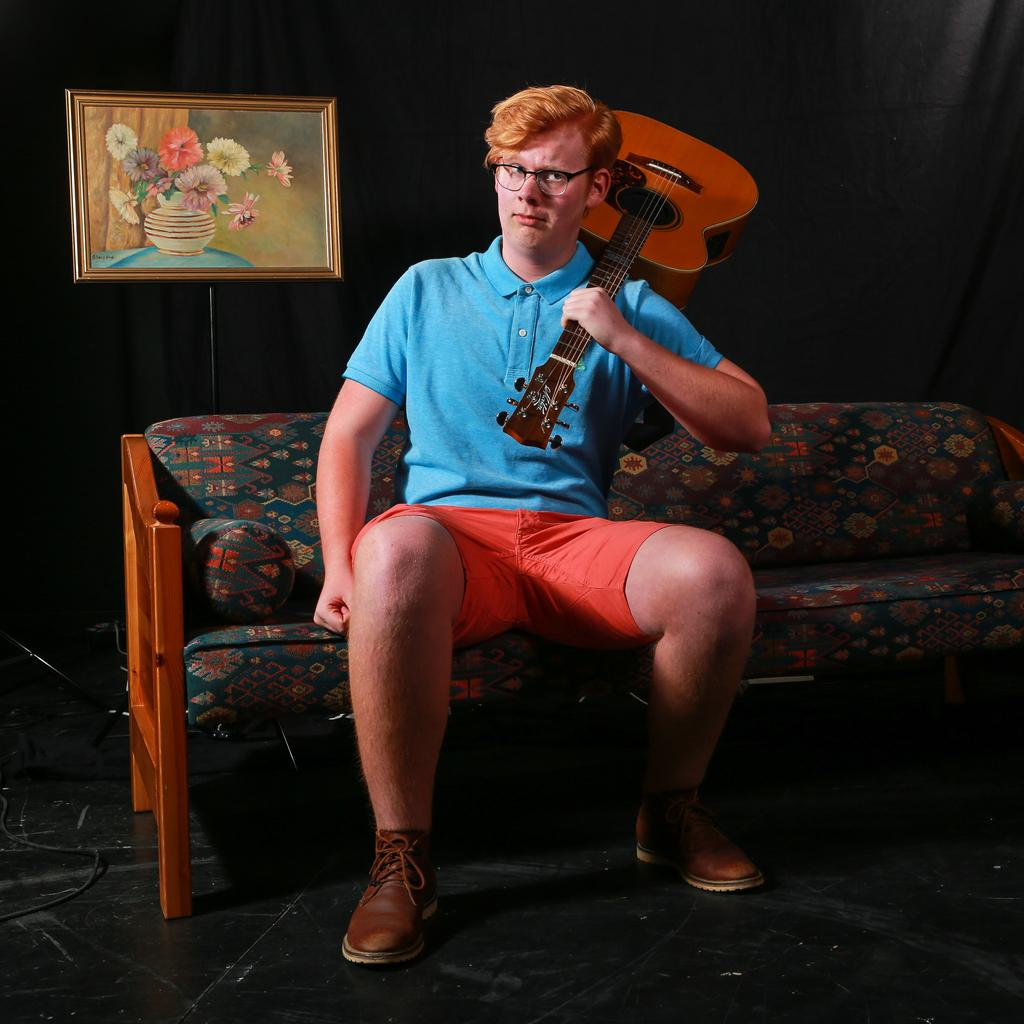What is the person in the image doing? The person is sitting on a sofa and holding a guitar on their shoulder. What can be seen in the background of the image? There is a black color curtain and a frame in the background of the image. What type of grain is being used as an example in the image? There is no grain present in the image; it features a person sitting on a sofa holding a guitar. 